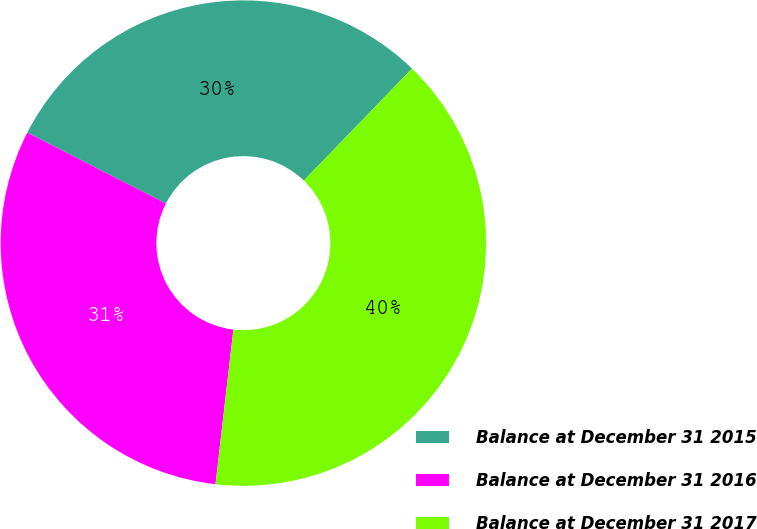<chart> <loc_0><loc_0><loc_500><loc_500><pie_chart><fcel>Balance at December 31 2015<fcel>Balance at December 31 2016<fcel>Balance at December 31 2017<nl><fcel>29.7%<fcel>30.69%<fcel>39.6%<nl></chart> 